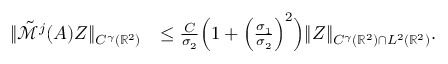Convert formula to latex. <formula><loc_0><loc_0><loc_500><loc_500>\begin{array} { r l } { \| \tilde { \mathcal { M } } ^ { j } ( A ) Z \| _ { C ^ { \gamma } ( \mathbb { R } ^ { 2 } ) } } & { \leq \frac { C } { \sigma _ { 2 } } \left ( 1 + \left ( \frac { \sigma _ { 1 } } { \sigma _ { 2 } } \right ) ^ { 2 } \right ) \| Z \| _ { C ^ { \gamma } ( \mathbb { R } ^ { 2 } ) \cap L ^ { 2 } ( \mathbb { R } ^ { 2 } ) } . } \end{array}</formula> 